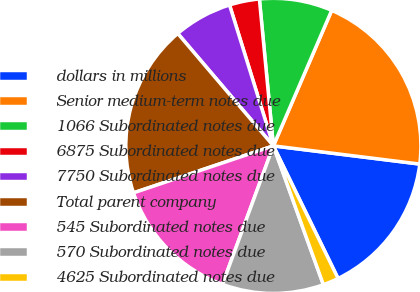Convert chart. <chart><loc_0><loc_0><loc_500><loc_500><pie_chart><fcel>dollars in millions<fcel>Senior medium-term notes due<fcel>1066 Subordinated notes due<fcel>6875 Subordinated notes due<fcel>7750 Subordinated notes due<fcel>Total parent company<fcel>545 Subordinated notes due<fcel>570 Subordinated notes due<fcel>4625 Subordinated notes due<nl><fcel>15.81%<fcel>20.5%<fcel>7.98%<fcel>3.29%<fcel>6.42%<fcel>18.94%<fcel>14.24%<fcel>11.11%<fcel>1.72%<nl></chart> 